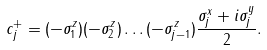<formula> <loc_0><loc_0><loc_500><loc_500>c _ { j } ^ { + } = ( - \sigma _ { 1 } ^ { z } ) ( - \sigma _ { 2 } ^ { z } ) \dots ( - \sigma _ { j - 1 } ^ { z } ) \frac { \sigma _ { j } ^ { x } + i \sigma _ { j } ^ { y } } { 2 } .</formula> 